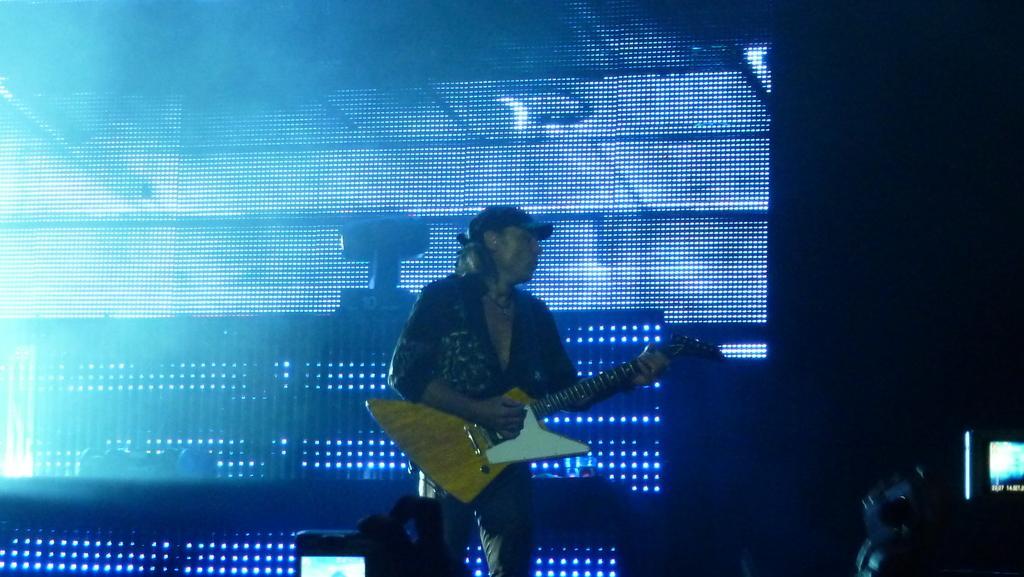Please provide a concise description of this image. Here we can see a person playing a guitar and he is wearing a cap and behind him we can see colorful lights background present 